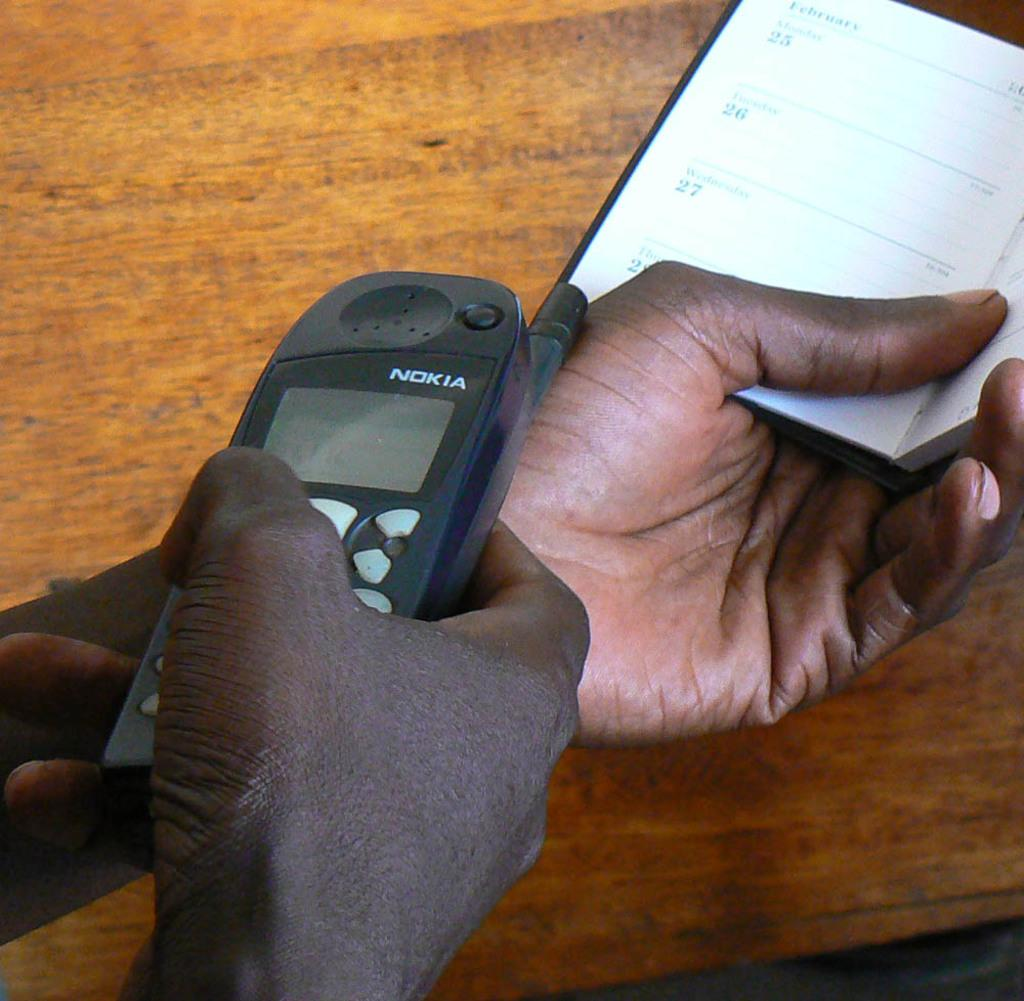<image>
Write a terse but informative summary of the picture. old nokia black cell phone in somebodys house 